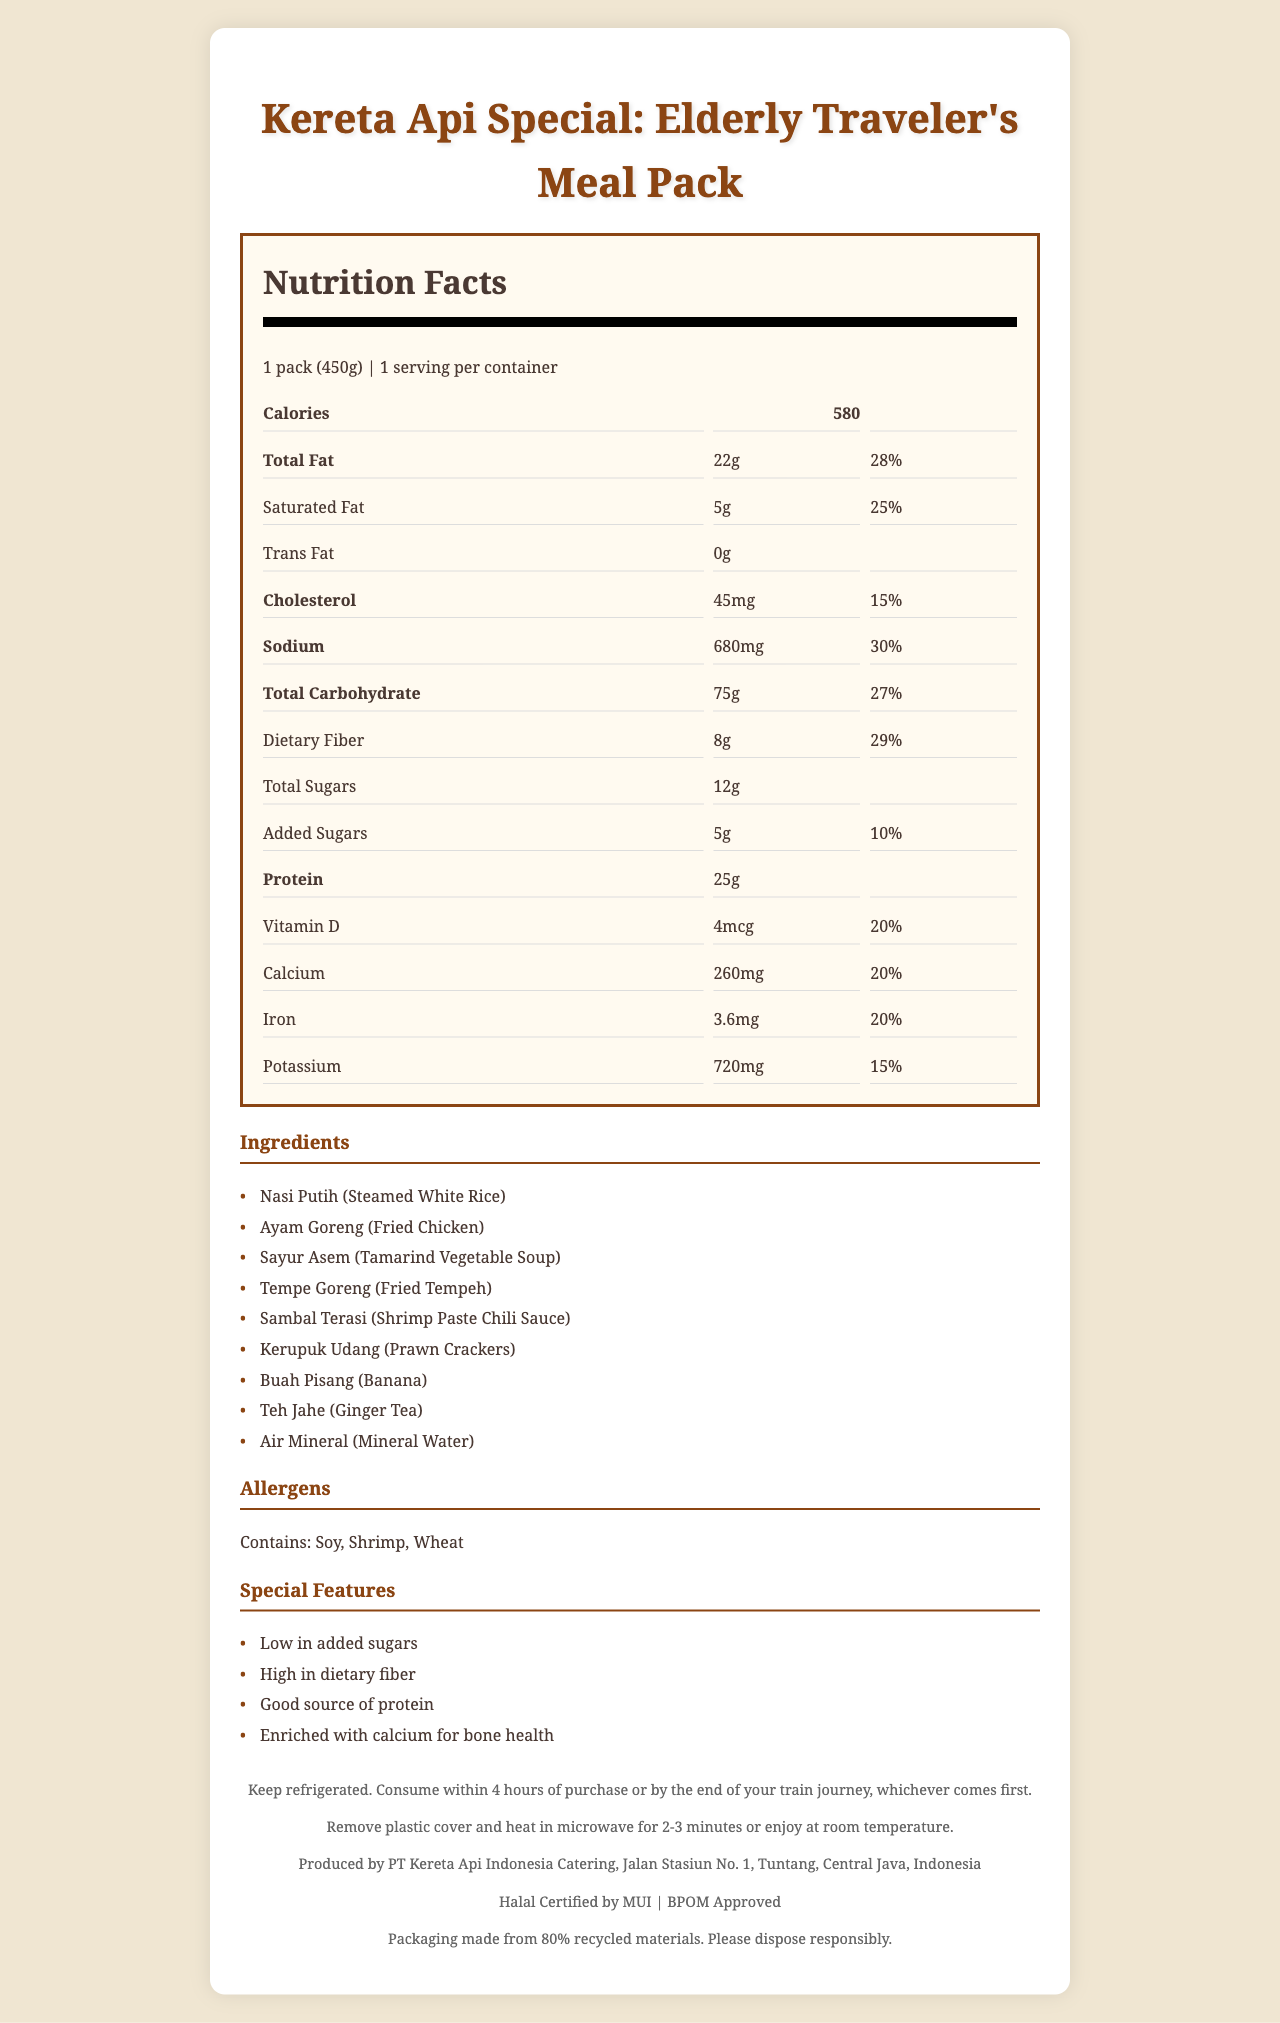what is the serving size of the meal pack? The serving size is clearly stated as "1 pack (450g)" in the document's nutrition label section.
Answer: 1 pack (450g) how many calories are there in one serving? The number of calories is listed as 580 in the nutrition label section.
Answer: 580 what are the main allergens present in this meal pack? The allergens section lists the main allergens as Soy, Shrimp, and Wheat.
Answer: Soy, Shrimp, Wheat what is the daily value percentage of dietary fiber? In the nutrition facts section, the daily value percentage of dietary fiber is listed as 29%.
Answer: 29% what are the main ingredients of the meal pack? The ingredients section lists all the ingredients included in the meal pack.
Answer: Nasi Putih (Steamed White Rice), Ayam Goreng (Fried Chicken), Sayur Asem (Tamarind Vegetable Soup), Tempe Goreng (Fried Tempeh), Sambal Terasi (Shrimp Paste Chili Sauce), Kerupuk Udang (Prawn Crackers), Buah Pisang (Banana), Teh Jahe (Ginger Tea), Air Mineral (Mineral Water) how much sodium does this meal pack contain? The sodium content is listed as 680mg in the nutrition facts section.
Answer: 680mg which of the following is listed as a special feature of this meal pack? 
A. Good source of Vitamin C 
B. High in dietary fiber 
C. Gluten-free 
D. Sugar-free The special features section lists "High in dietary fiber" as one of the features.
Answer: B how much protein is in the meal pack? The amount of protein is listed as 25g in the nutrition facts section.
Answer: 25g are there any trans fats in the meal pack? The nutrition facts section states that there are 0g of trans fats.
Answer: No what certifications does this meal pack have? 
i. Halal Certified by MUI 
ii. BPOM Approved 
iii. ISO Certified 
iv. USDA Organic Certified The certifications section lists "Halal Certified by MUI" and "BPOM Approved".
Answer: i and ii how should the meal pack be stored and consumed? The storage instructions section provides this detailed storage and consumption information.
Answer: Keep refrigerated. Consume within 4 hours of purchase or by the end of your train journey, whichever comes first. what is the daily value percentage of calcium in the meal pack? In the nutrition facts section, the daily value percentage of calcium is listed as 20%.
Answer: 20% what feature supports the bone health of elderly passengers? The special features section mentions "Enriched with calcium for bone health".
Answer: Enriched with calcium for bone health what is the amount of added sugars in the meal pack? The nutrition facts section lists added sugars as 5g.
Answer: 5g what should you do with the packaging after finishing the meal pack? The sustainability note at the end of the document instructs to dispose of the packaging responsibly.
Answer: Dispose responsibly which ingredient is used for the chili sauce? The ingredient "Sambal Terasi (Shrimp Paste Chili Sauce)" indicates that shrimp paste is used in the chili sauce.
Answer: Shrimp Paste what is special about the packaging material of the meal pack? The sustainability note mentions that the packaging is made from 80% recycled materials.
Answer: Made from 80% recycled materials does the document provide information on the company history of PT Kereta Api Indonesia Catering? The document does not provide any historical or background information on the company, only manufacturer information.
Answer: Not enough information summarize the main features and content of the document. The summary captures the main sections and highlights the essential aspects of the meal pack described in the document.
Answer: The document provides the nutrition facts and detailed information about the "Kereta Api Special: Elderly Traveler’s Meal Pack." It includes serving size, calories, fat content, sodium, carbohydrates, protein, vitamins, and minerals. Additional features highlight that it's low in added sugars, high in dietary fiber, a good source of protein, and enriched with calcium. The ingredients, allergens, storage and heating instructions, certifications, and sustainability note are also provided. 